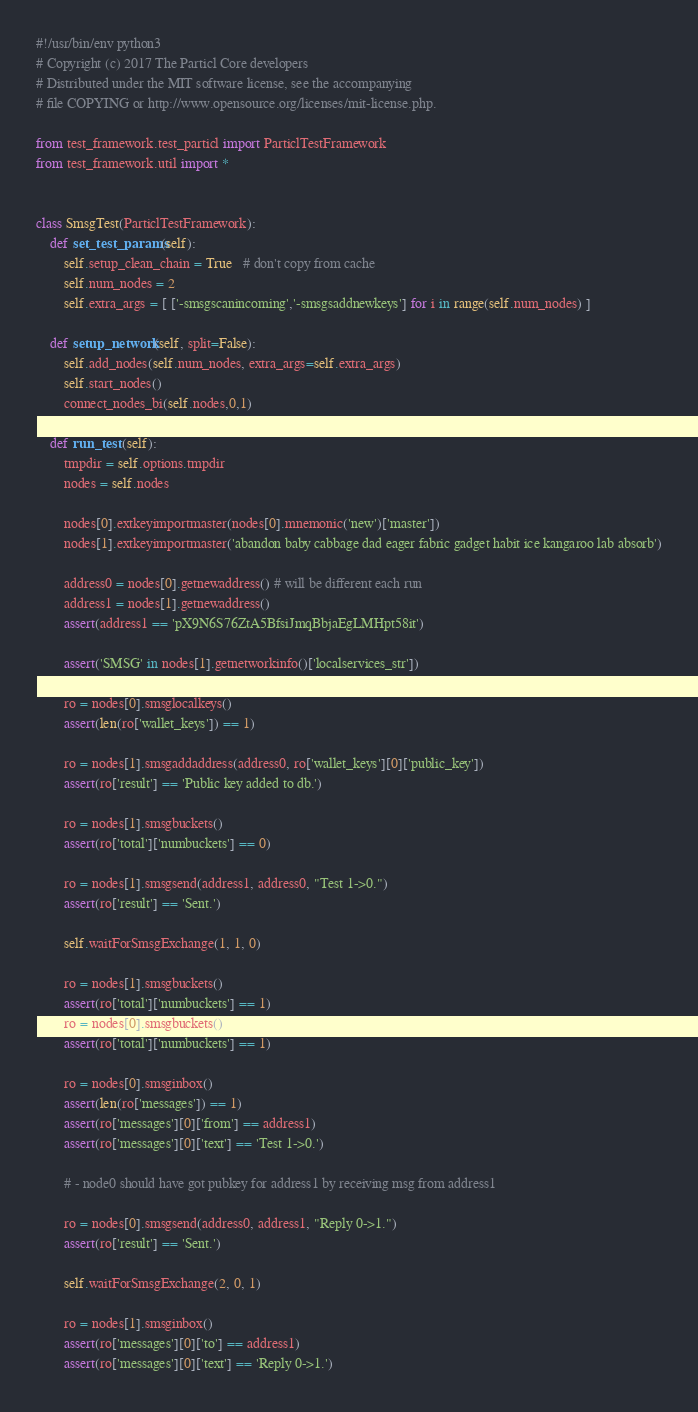<code> <loc_0><loc_0><loc_500><loc_500><_Python_>#!/usr/bin/env python3
# Copyright (c) 2017 The Particl Core developers
# Distributed under the MIT software license, see the accompanying
# file COPYING or http://www.opensource.org/licenses/mit-license.php.

from test_framework.test_particl import ParticlTestFramework
from test_framework.util import *


class SmsgTest(ParticlTestFramework):
    def set_test_params(self):
        self.setup_clean_chain = True   # don't copy from cache
        self.num_nodes = 2
        self.extra_args = [ ['-smsgscanincoming','-smsgsaddnewkeys'] for i in range(self.num_nodes) ]

    def setup_network(self, split=False):
        self.add_nodes(self.num_nodes, extra_args=self.extra_args)
        self.start_nodes()
        connect_nodes_bi(self.nodes,0,1)

    def run_test (self):
        tmpdir = self.options.tmpdir
        nodes = self.nodes

        nodes[0].extkeyimportmaster(nodes[0].mnemonic('new')['master'])
        nodes[1].extkeyimportmaster('abandon baby cabbage dad eager fabric gadget habit ice kangaroo lab absorb')

        address0 = nodes[0].getnewaddress() # will be different each run
        address1 = nodes[1].getnewaddress()
        assert(address1 == 'pX9N6S76ZtA5BfsiJmqBbjaEgLMHpt58it')

        assert('SMSG' in nodes[1].getnetworkinfo()['localservices_str'])

        ro = nodes[0].smsglocalkeys()
        assert(len(ro['wallet_keys']) == 1)

        ro = nodes[1].smsgaddaddress(address0, ro['wallet_keys'][0]['public_key'])
        assert(ro['result'] == 'Public key added to db.')

        ro = nodes[1].smsgbuckets()
        assert(ro['total']['numbuckets'] == 0)

        ro = nodes[1].smsgsend(address1, address0, "Test 1->0.")
        assert(ro['result'] == 'Sent.')

        self.waitForSmsgExchange(1, 1, 0)

        ro = nodes[1].smsgbuckets()
        assert(ro['total']['numbuckets'] == 1)
        ro = nodes[0].smsgbuckets()
        assert(ro['total']['numbuckets'] == 1)

        ro = nodes[0].smsginbox()
        assert(len(ro['messages']) == 1)
        assert(ro['messages'][0]['from'] == address1)
        assert(ro['messages'][0]['text'] == 'Test 1->0.')

        # - node0 should have got pubkey for address1 by receiving msg from address1

        ro = nodes[0].smsgsend(address0, address1, "Reply 0->1.")
        assert(ro['result'] == 'Sent.')

        self.waitForSmsgExchange(2, 0, 1)

        ro = nodes[1].smsginbox()
        assert(ro['messages'][0]['to'] == address1)
        assert(ro['messages'][0]['text'] == 'Reply 0->1.')

</code> 